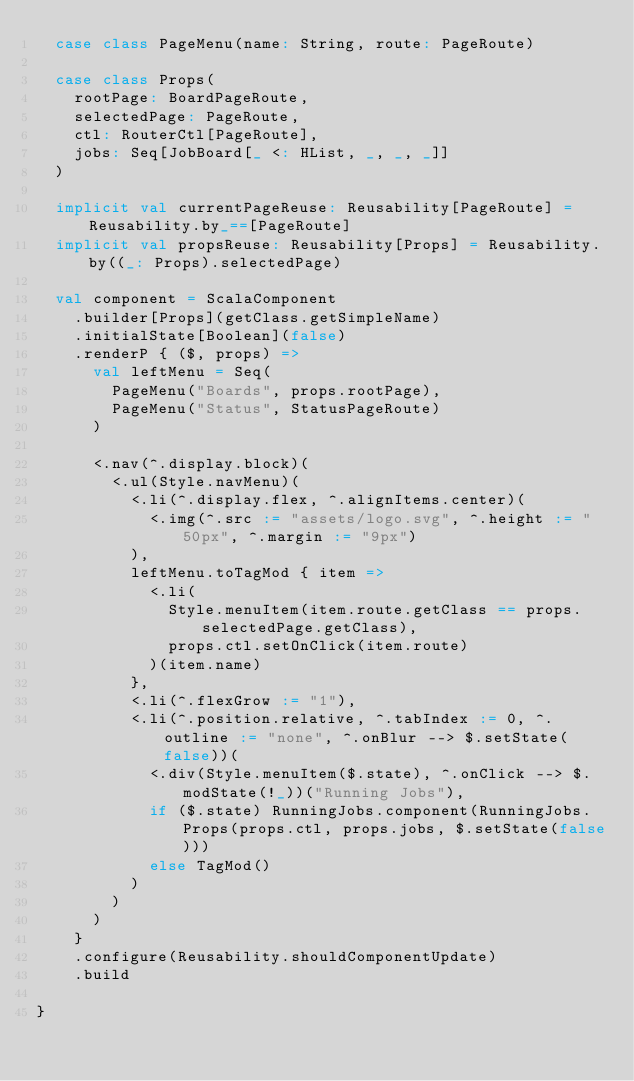<code> <loc_0><loc_0><loc_500><loc_500><_Scala_>  case class PageMenu(name: String, route: PageRoute)

  case class Props(
    rootPage: BoardPageRoute,
    selectedPage: PageRoute,
    ctl: RouterCtl[PageRoute],
    jobs: Seq[JobBoard[_ <: HList, _, _, _]]
  )

  implicit val currentPageReuse: Reusability[PageRoute] = Reusability.by_==[PageRoute]
  implicit val propsReuse: Reusability[Props] = Reusability.by((_: Props).selectedPage)

  val component = ScalaComponent
    .builder[Props](getClass.getSimpleName)
    .initialState[Boolean](false)
    .renderP { ($, props) =>
      val leftMenu = Seq(
        PageMenu("Boards", props.rootPage),
        PageMenu("Status", StatusPageRoute)
      )

      <.nav(^.display.block)(
        <.ul(Style.navMenu)(
          <.li(^.display.flex, ^.alignItems.center)(
            <.img(^.src := "assets/logo.svg", ^.height := "50px", ^.margin := "9px")
          ),
          leftMenu.toTagMod { item =>
            <.li(
              Style.menuItem(item.route.getClass == props.selectedPage.getClass),
              props.ctl.setOnClick(item.route)
            )(item.name)
          },
          <.li(^.flexGrow := "1"),
          <.li(^.position.relative, ^.tabIndex := 0, ^.outline := "none", ^.onBlur --> $.setState(false))(
            <.div(Style.menuItem($.state), ^.onClick --> $.modState(!_))("Running Jobs"),
            if ($.state) RunningJobs.component(RunningJobs.Props(props.ctl, props.jobs, $.setState(false)))
            else TagMod()
          )
        )
      )
    }
    .configure(Reusability.shouldComponentUpdate)
    .build

}
</code> 